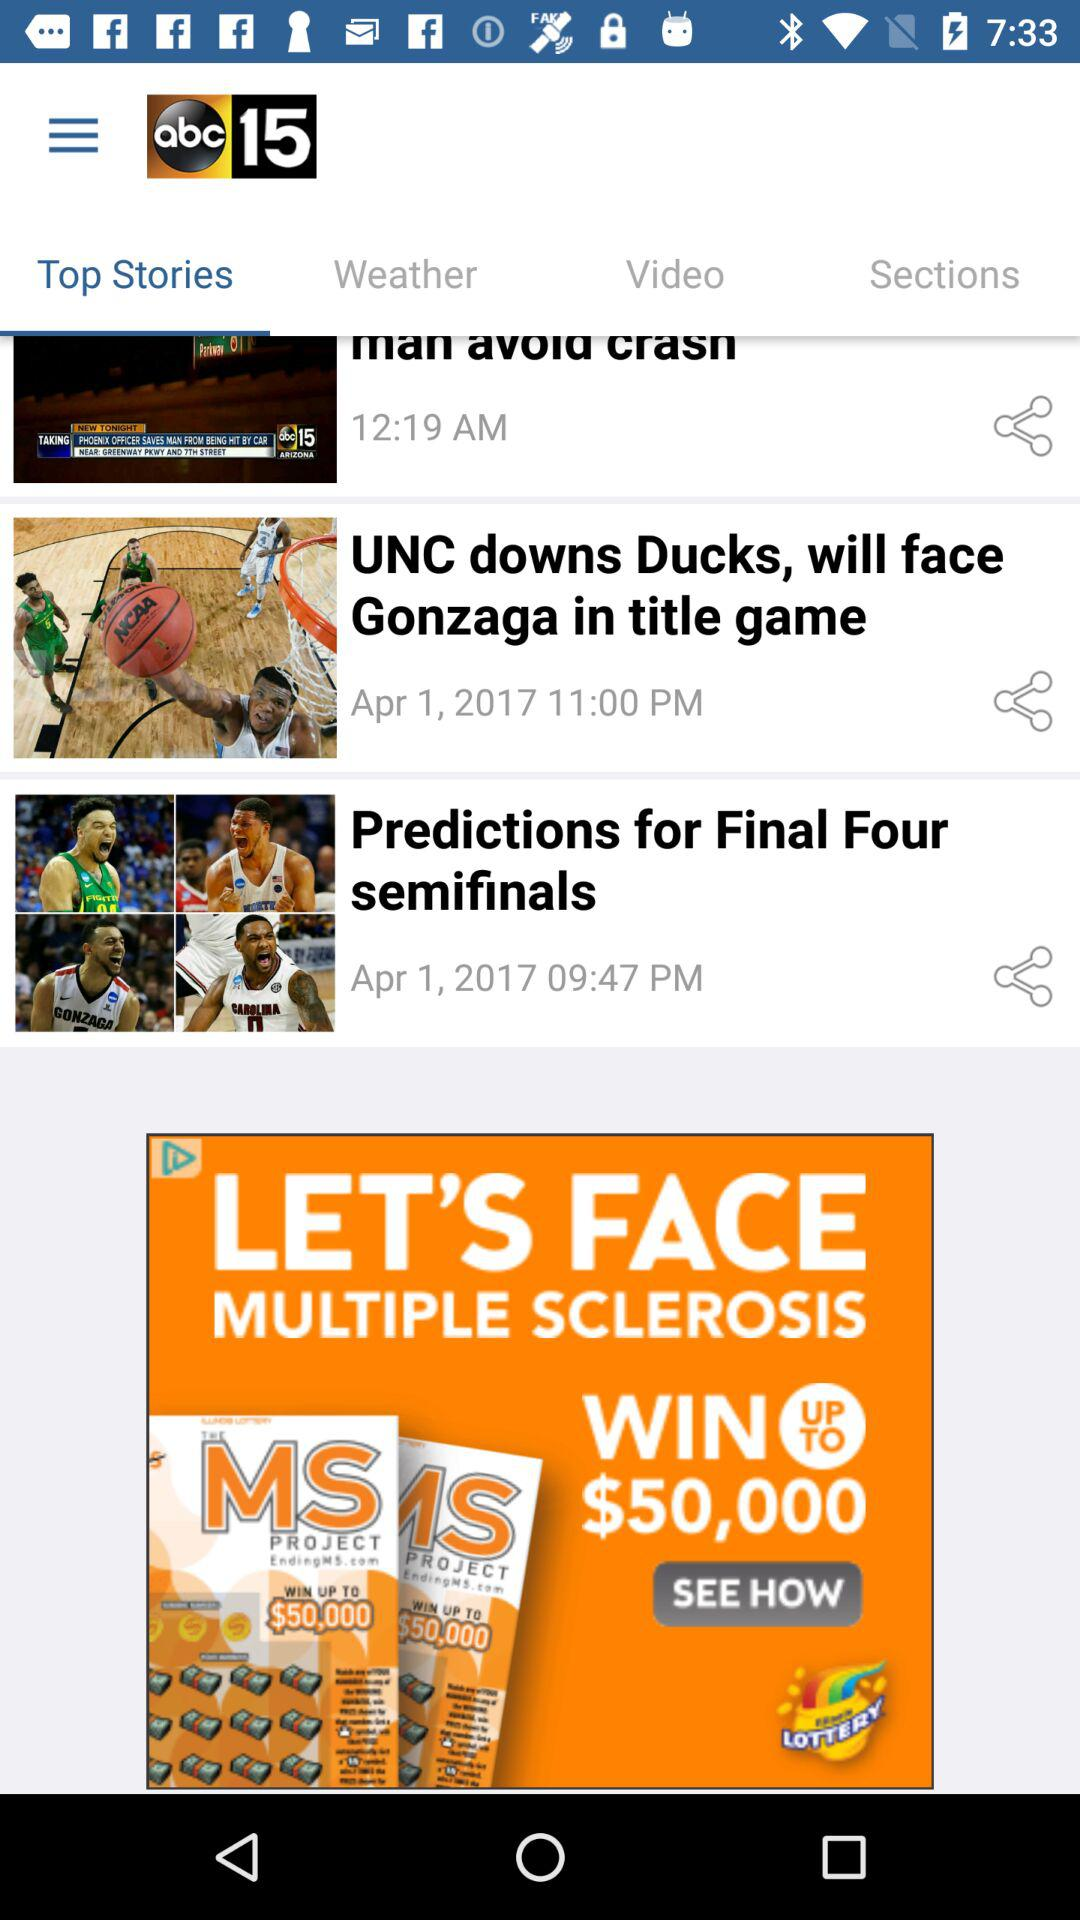On which date was the news "Predictions for Final Four semifinals" published? The news "Predictions for Final Four semifinals" was published on April 1, 2017. 